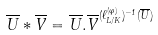<formula> <loc_0><loc_0><loc_500><loc_500>\overline { U } \ast \overline { V } = \overline { U } . \overline { V } ^ { ( \ell _ { L / K } ^ { ( \varphi ) } ) ^ { - 1 } ( \overline { U } ) }</formula> 